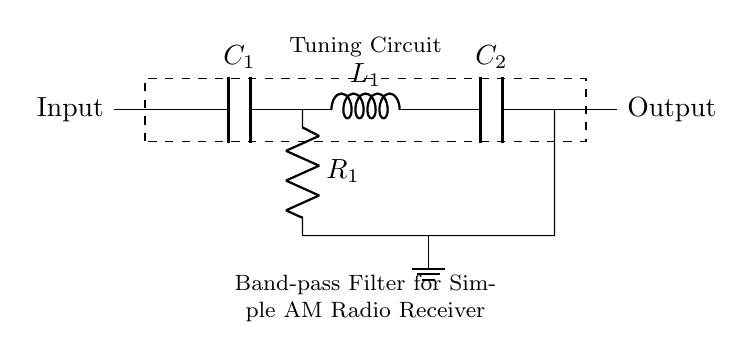What components are present in the circuit? The circuit includes two capacitors labeled as C1 and C2, one inductor labeled as L1, and one resistor labeled as R1.
Answer: C1, C2, L1, R1 What does the dashed rectangle represent? The dashed rectangle surrounds the tuning circuit that signifies the function of the components inside, which is to select a specific frequency range.
Answer: Tuning Circuit What is the function of a band-pass filter? A band-pass filter allows signals within a certain frequency range to pass while attenuating frequencies outside that range.
Answer: Signal selection What is connected to ground in this circuit? The inductor L1 is connected to ground through the resistor R1, which provides a reference point in the circuit.
Answer: Resistor R1 What is the input to the circuit? The input is connected to the left side of the circuit, where it receives signals from the antenna, which can be an AM radio signal.
Answer: Input signal Why is a band-pass filter used in an AM radio receiver? It filters out unwanted signals and noise, allowing only the specific frequency of the AM signal to be amplified for better reception.
Answer: Noise reduction 